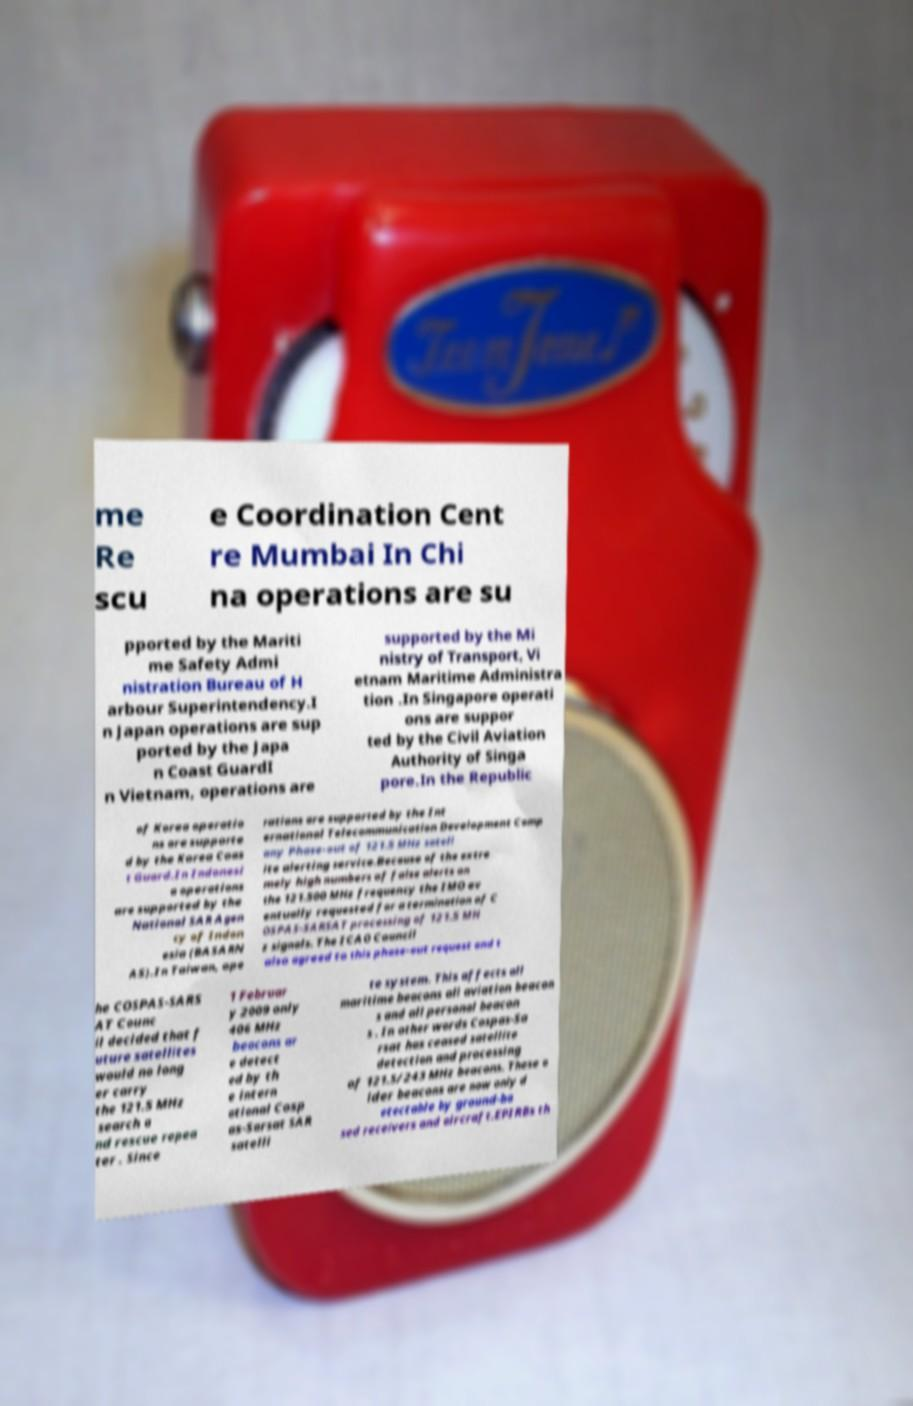Please identify and transcribe the text found in this image. me Re scu e Coordination Cent re Mumbai In Chi na operations are su pported by the Mariti me Safety Admi nistration Bureau of H arbour Superintendency.I n Japan operations are sup ported by the Japa n Coast GuardI n Vietnam, operations are supported by the Mi nistry of Transport, Vi etnam Maritime Administra tion .In Singapore operati ons are suppor ted by the Civil Aviation Authority of Singa pore.In the Republic of Korea operatio ns are supporte d by the Korea Coas t Guard.In Indonesi a operations are supported by the National SAR Agen cy of Indon esia (BASARN AS).In Taiwan, ope rations are supported by the Int ernational Telecommunication Development Comp any Phase-out of 121.5 MHz satell ite alerting service.Because of the extre mely high numbers of false alerts on the 121.500 MHz frequency the IMO ev entually requested for a termination of C OSPAS-SARSAT processing of 121.5 MH z signals. The ICAO Council also agreed to this phase-out request and t he COSPAS-SARS AT Counc il decided that f uture satellites would no long er carry the 121.5 MHz search a nd rescue repea ter . Since 1 Februar y 2009 only 406 MHz beacons ar e detect ed by th e intern ational Cosp as-Sarsat SAR satelli te system. This affects all maritime beacons all aviation beacon s and all personal beacon s . In other words Cospas-Sa rsat has ceased satellite detection and processing of 121.5/243 MHz beacons. These o lder beacons are now only d etectable by ground-ba sed receivers and aircraft.EPIRBs th 